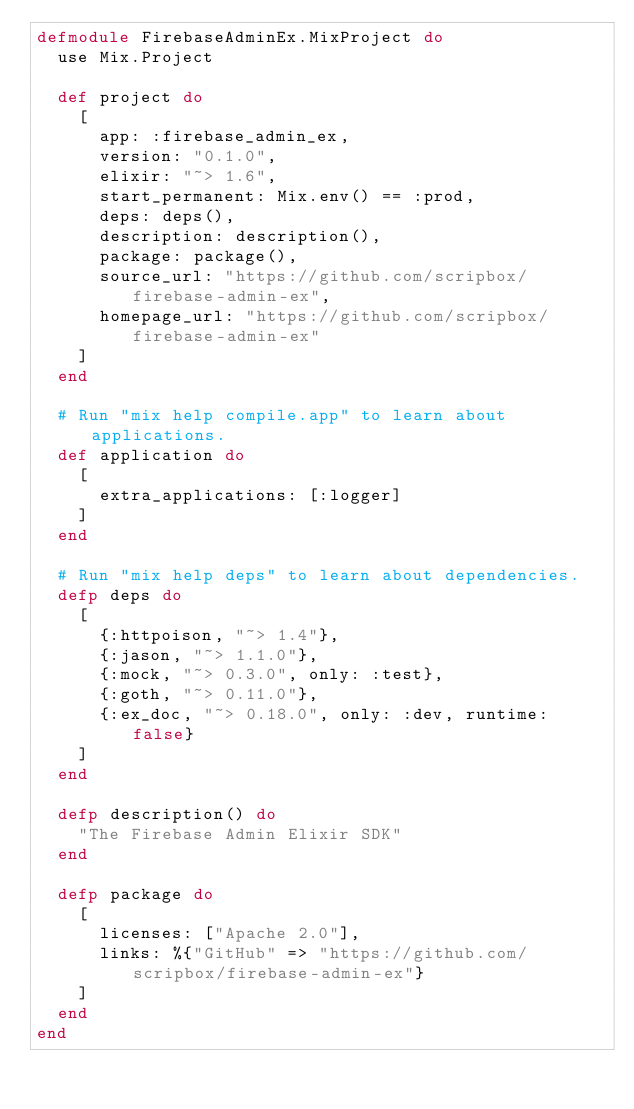<code> <loc_0><loc_0><loc_500><loc_500><_Elixir_>defmodule FirebaseAdminEx.MixProject do
  use Mix.Project

  def project do
    [
      app: :firebase_admin_ex,
      version: "0.1.0",
      elixir: "~> 1.6",
      start_permanent: Mix.env() == :prod,
      deps: deps(),
      description: description(),
      package: package(),
      source_url: "https://github.com/scripbox/firebase-admin-ex",
      homepage_url: "https://github.com/scripbox/firebase-admin-ex"
    ]
  end

  # Run "mix help compile.app" to learn about applications.
  def application do
    [
      extra_applications: [:logger]
    ]
  end

  # Run "mix help deps" to learn about dependencies.
  defp deps do
    [
      {:httpoison, "~> 1.4"},
      {:jason, "~> 1.1.0"},
      {:mock, "~> 0.3.0", only: :test},
      {:goth, "~> 0.11.0"},
      {:ex_doc, "~> 0.18.0", only: :dev, runtime: false}
    ]
  end

  defp description() do
    "The Firebase Admin Elixir SDK"
  end

  defp package do
    [
      licenses: ["Apache 2.0"],
      links: %{"GitHub" => "https://github.com/scripbox/firebase-admin-ex"}
    ]
  end
end
</code> 